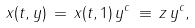Convert formula to latex. <formula><loc_0><loc_0><loc_500><loc_500>x ( t , y ) \, = \, x ( t , 1 ) \, y ^ { c } \, \equiv \, z \, y ^ { c } ,</formula> 